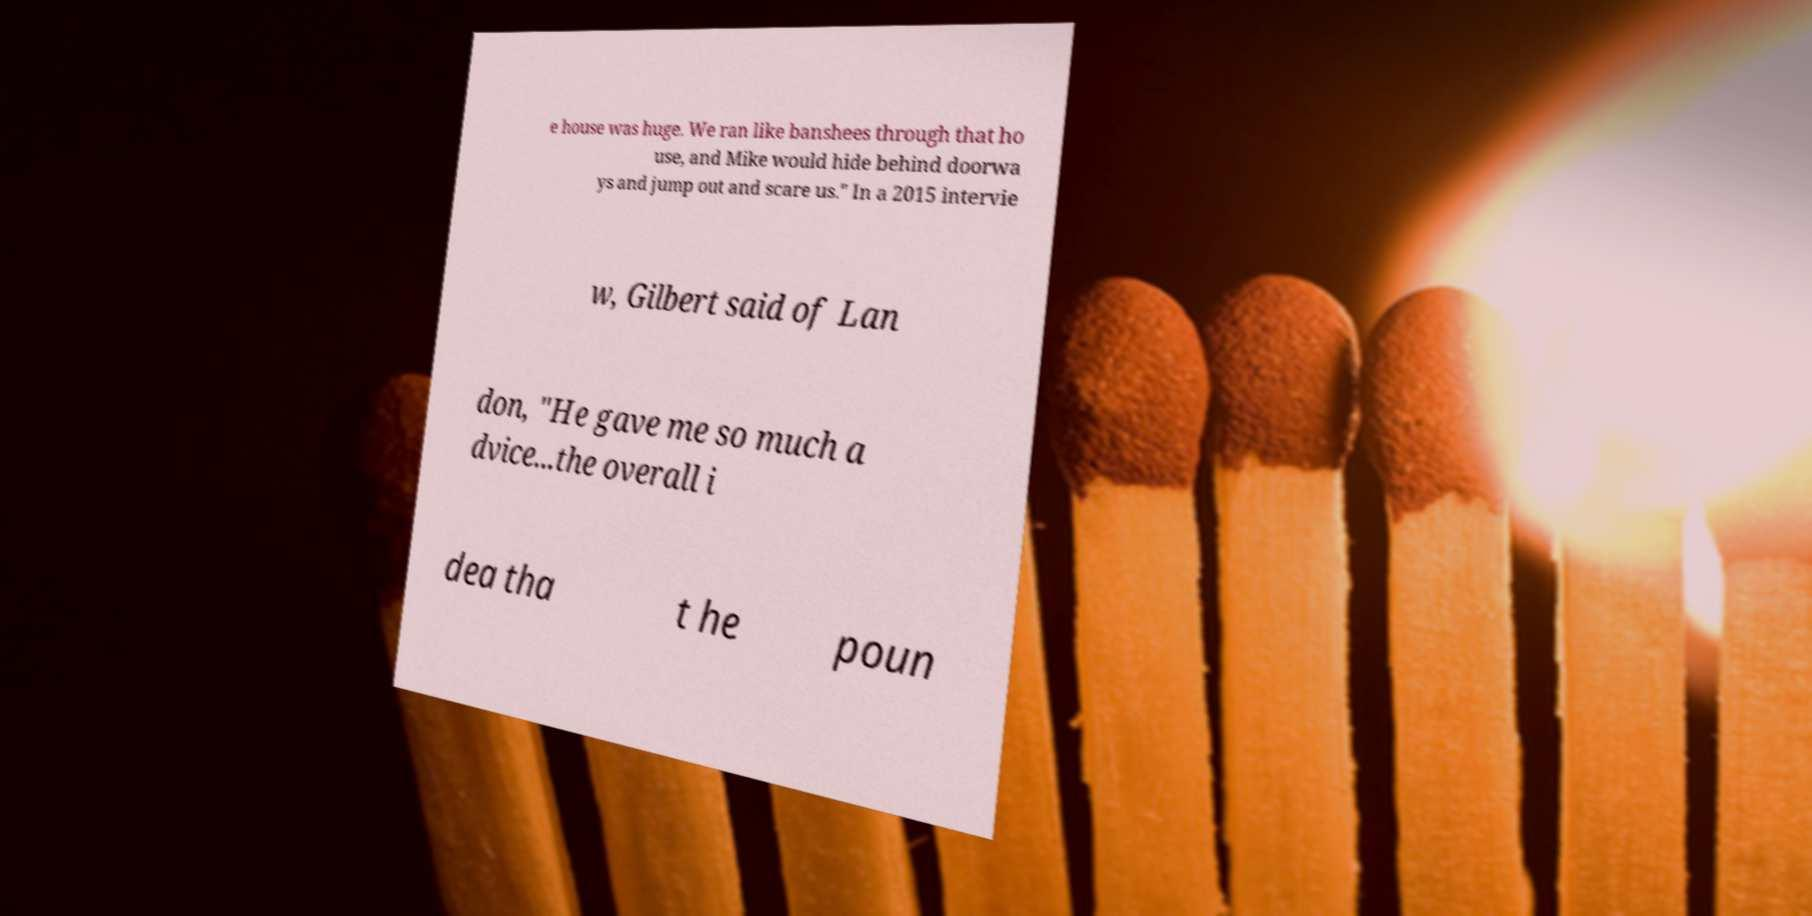Can you read and provide the text displayed in the image?This photo seems to have some interesting text. Can you extract and type it out for me? e house was huge. We ran like banshees through that ho use, and Mike would hide behind doorwa ys and jump out and scare us." In a 2015 intervie w, Gilbert said of Lan don, "He gave me so much a dvice...the overall i dea tha t he poun 